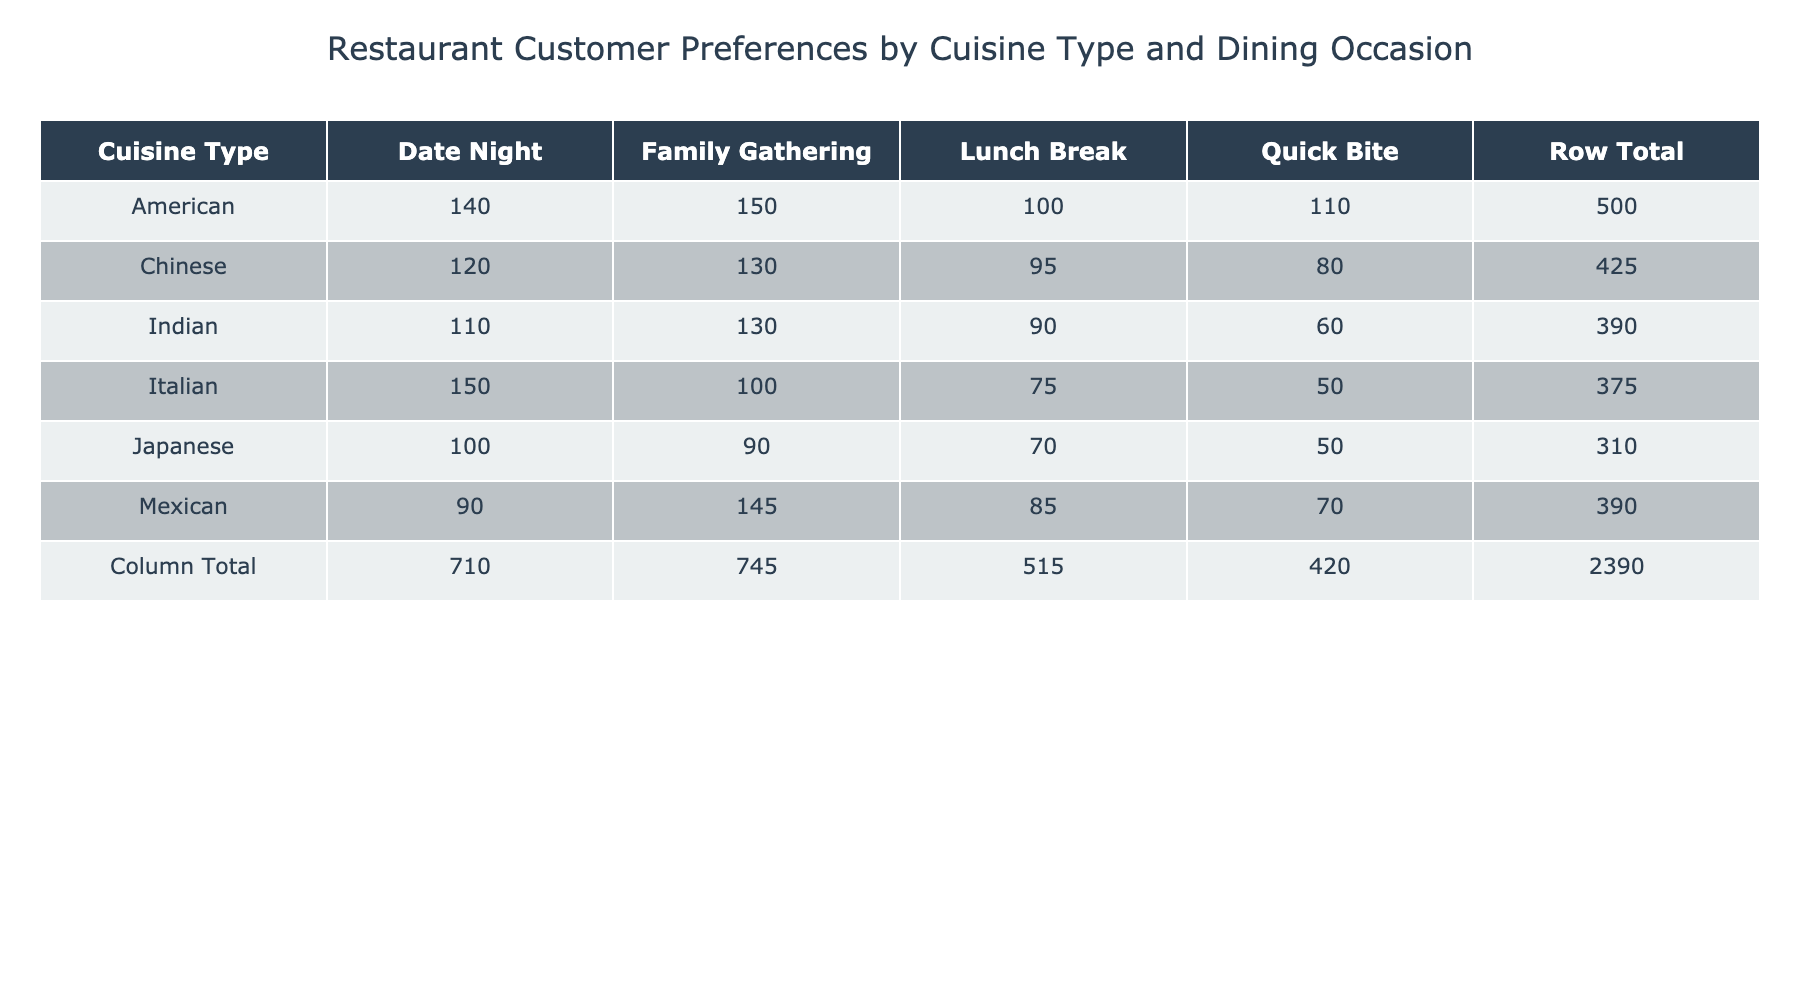What cuisine type has the highest customer preference count for Date Night? In the table, we look at the "Date Night" column for each cuisine type. The maximum value is for the American cuisine, which has a preference count of 140.
Answer: American What is the total customer preference count for Italian cuisine across all dining occasions? We sum the values in the Italian row: 150 (Date Night) + 100 (Family Gathering) + 75 (Lunch Break) + 50 (Quick Bite) = 375.
Answer: 375 Is there a cuisine type that customers prefer equally for Lunch Break and Quick Bite? Checking the "Lunch Break" and "Quick Bite" columns, we see that no cuisine type has the same count for these two occasions; they are all different.
Answer: No What dining occasion has the highest total customer preference count across all cuisine types? We sum the counts for each occasion: Date Night (150 + 120 + 90 + 110 + 140 + 100) = 810, Family Gathering (100 + 130 + 145 + 130 + 150 + 90) = 945, Lunch Break (75 + 95 + 85 + 90 + 100 + 70) = 510, Quick Bite (50 + 80 + 70 + 60 + 110 + 50) = 420. The highest total is 945 for Family Gathering.
Answer: Family Gathering What is the average customer preference count for Mexican cuisine? The values for Mexican are 90 (Date Night), 145 (Family Gathering), 85 (Lunch Break), and 70 (Quick Bite). Their sum is 90 + 145 + 85 + 70 = 390, and with 4 dining occasions, the average is 390/4 = 97.5.
Answer: 97.5 Which cuisine type has the lowest preference count for any dining occasion? By examining the counts in the table, we find that the Quick Bite option for Japanese cuisine has the lowest count of 50.
Answer: Japanese How many more customer preferences does American cuisine have than Indian cuisine for Family Gatherings? For family gatherings, American has 150 preferences and Indian has 130 preferences. The difference is 150 - 130 = 20.
Answer: 20 Which cuisine type has the highest preference count for Lunch Break? Analyzing the Lunch Break column, we see that American cuisine has 100, which is the highest compared to other cuisines.
Answer: American 